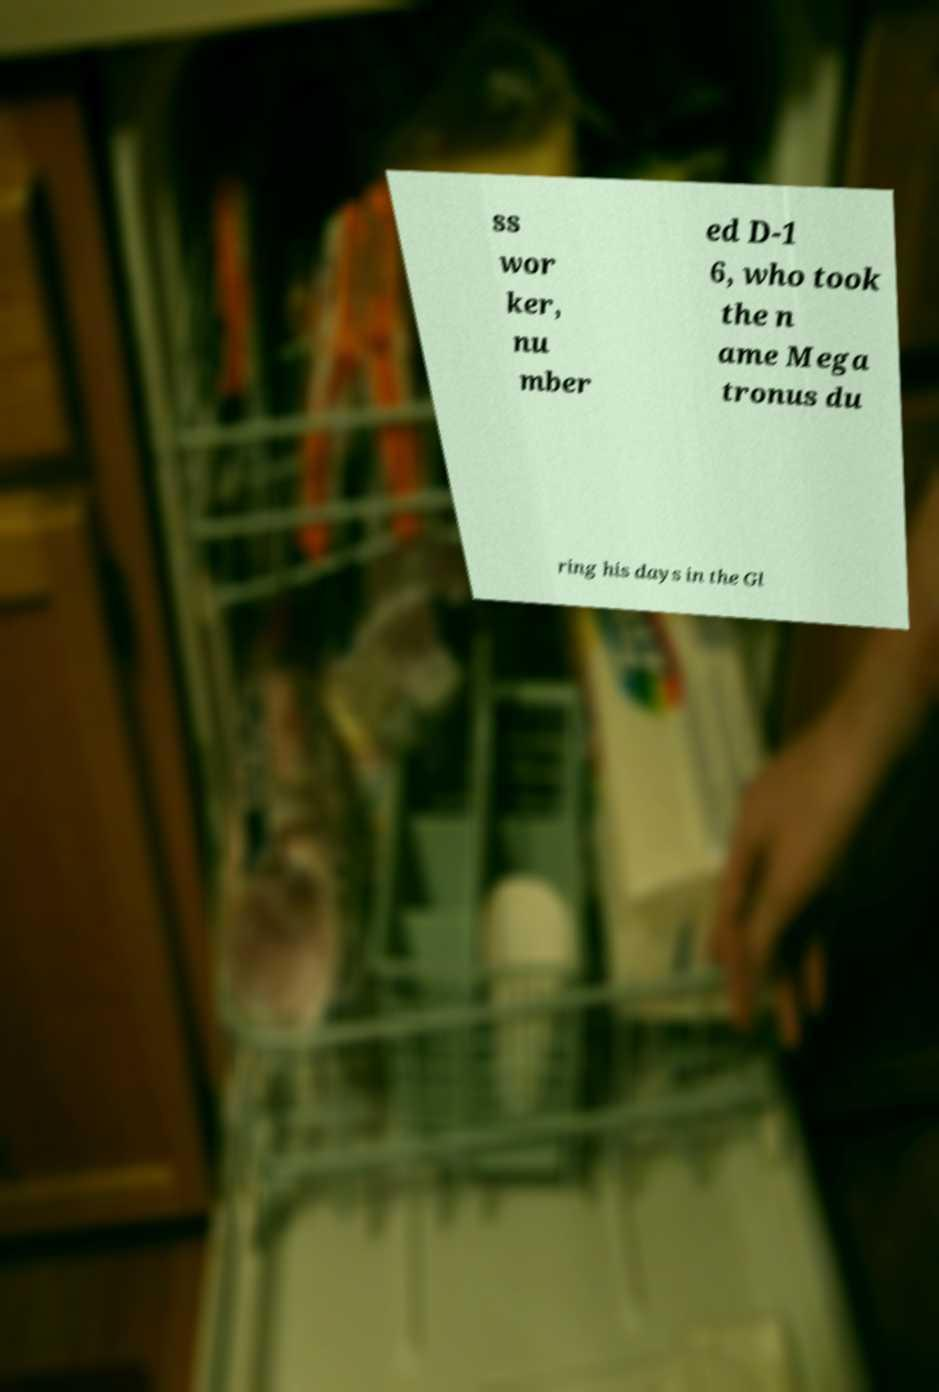There's text embedded in this image that I need extracted. Can you transcribe it verbatim? ss wor ker, nu mber ed D-1 6, who took the n ame Mega tronus du ring his days in the Gl 